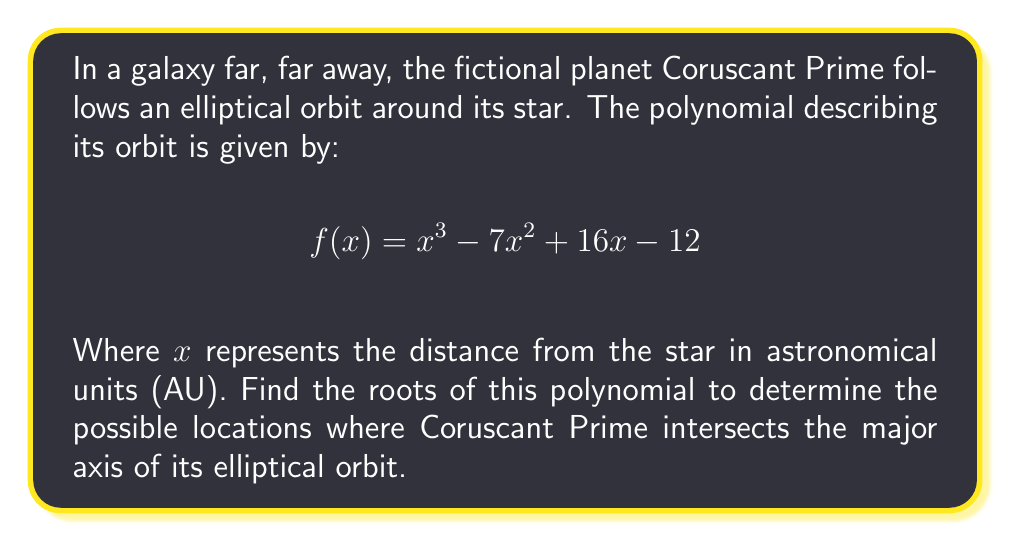Can you solve this math problem? To find the roots of the polynomial $f(x) = x^3 - 7x^2 + 16x - 12$, we'll use the following steps:

1) First, let's check if there's a rational root using the rational root theorem. The possible rational roots are the factors of the constant term: ±1, ±2, ±3, ±4, ±6, ±12.

2) Testing these values, we find that $f(1) = 0$. So $x = 1$ is a root.

3) We can now use polynomial long division to factor out $(x-1)$:

   $$x^3 - 7x^2 + 16x - 12 = (x-1)(x^2 - 6x + 12)$$

4) Now we need to solve the quadratic equation $x^2 - 6x + 12 = 0$

5) Using the quadratic formula $x = \frac{-b \pm \sqrt{b^2 - 4ac}}{2a}$:

   $$x = \frac{6 \pm \sqrt{36 - 48}}{2} = \frac{6 \pm \sqrt{-12}}{2} = 3 \pm i\sqrt{3}$$

6) Therefore, the roots of the polynomial are:
   $x_1 = 1$
   $x_2 = 3 + i\sqrt{3}$
   $x_3 = 3 - i\sqrt{3}$

These roots represent the points where Coruscant Prime's orbit intersects its elliptical major axis: once at 1 AU, and at two complex conjugate points which don't have physical meaning in this context.
Answer: $x_1 = 1$, $x_2 = 3 + i\sqrt{3}$, $x_3 = 3 - i\sqrt{3}$ 